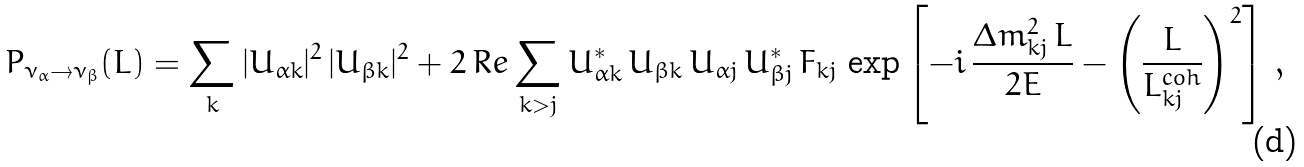Convert formula to latex. <formula><loc_0><loc_0><loc_500><loc_500>P _ { \nu _ { \alpha } \to \nu _ { \beta } } ( L ) = \sum _ { k } | U _ { { \alpha } k } | ^ { 2 } \, | U _ { { \beta } k } | ^ { 2 } + 2 \, R e \sum _ { k > j } U _ { { \alpha } k } ^ { * } \, U _ { { \beta } k } \, U _ { { \alpha } j } \, U _ { { \beta } j } ^ { * } \, F _ { k j } \, \exp \left [ - i \, \frac { \Delta { m } ^ { 2 } _ { k j } \, L } { 2 E } - \left ( \frac { L } { L _ { k j } ^ { c o h } } \right ) ^ { 2 } \right ] \, ,</formula> 